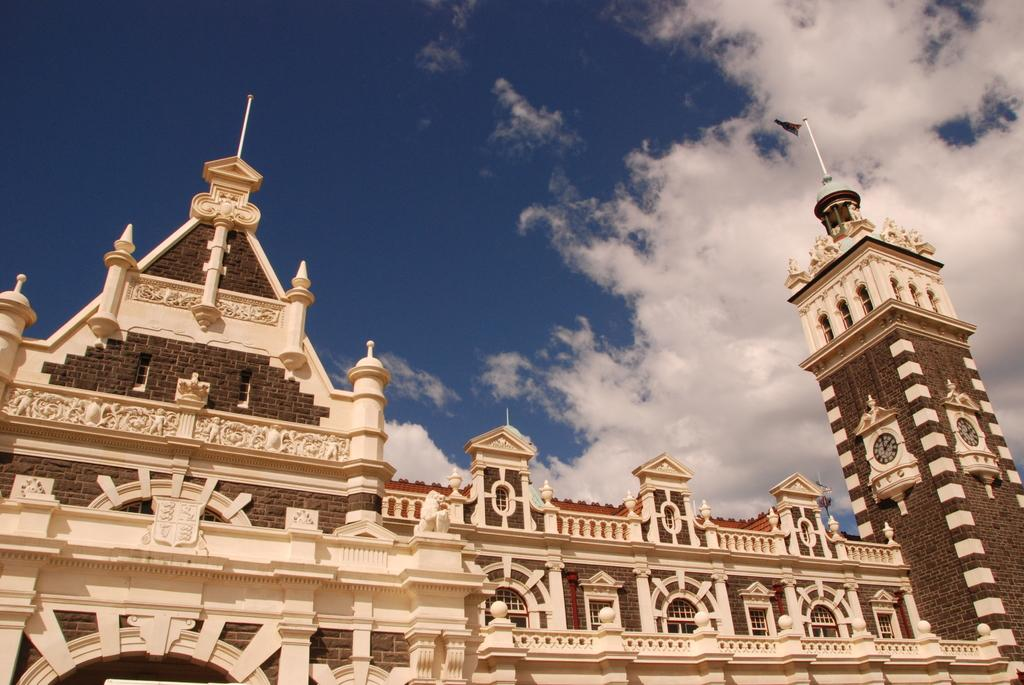What is the main structure in the image? There is a big monument in the image. Can you describe any specific features of the monument? There is a clock on the right side of the monument. What is the weather like in the image? The sky is sunny at the top of the image. How many trees are present in the image? There is no mention of trees in the provided facts, so we cannot determine the number of trees in the image. What type of powder is being used to say good-bye in the image? There is no mention of powder or good-bye in the provided facts, so we cannot determine if any such activity is taking place in the image. 